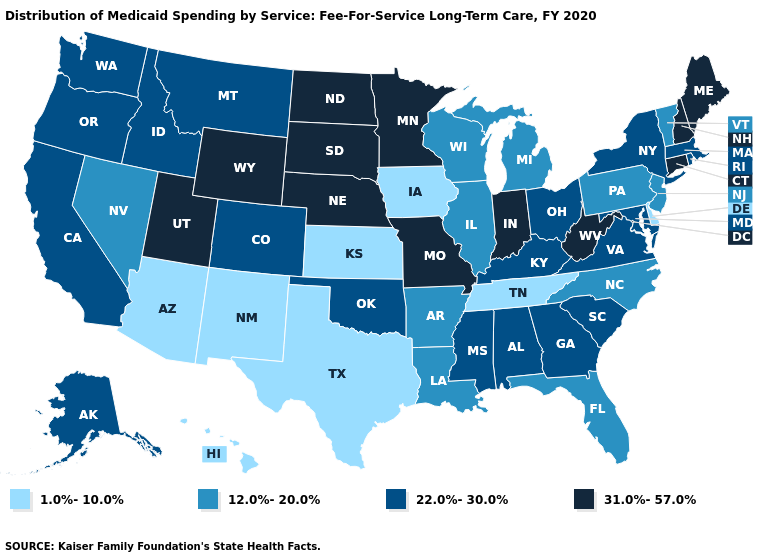What is the highest value in states that border South Carolina?
Write a very short answer. 22.0%-30.0%. What is the value of Wisconsin?
Answer briefly. 12.0%-20.0%. What is the lowest value in the South?
Keep it brief. 1.0%-10.0%. What is the value of Wyoming?
Answer briefly. 31.0%-57.0%. What is the lowest value in the South?
Be succinct. 1.0%-10.0%. Does Vermont have the highest value in the Northeast?
Give a very brief answer. No. Does Hawaii have the highest value in the West?
Answer briefly. No. Does Montana have the lowest value in the USA?
Be succinct. No. What is the highest value in the USA?
Short answer required. 31.0%-57.0%. Among the states that border North Carolina , does Tennessee have the highest value?
Concise answer only. No. Does North Carolina have a lower value than North Dakota?
Answer briefly. Yes. What is the value of Louisiana?
Answer briefly. 12.0%-20.0%. Does the map have missing data?
Write a very short answer. No. Does Indiana have the highest value in the MidWest?
Answer briefly. Yes. 